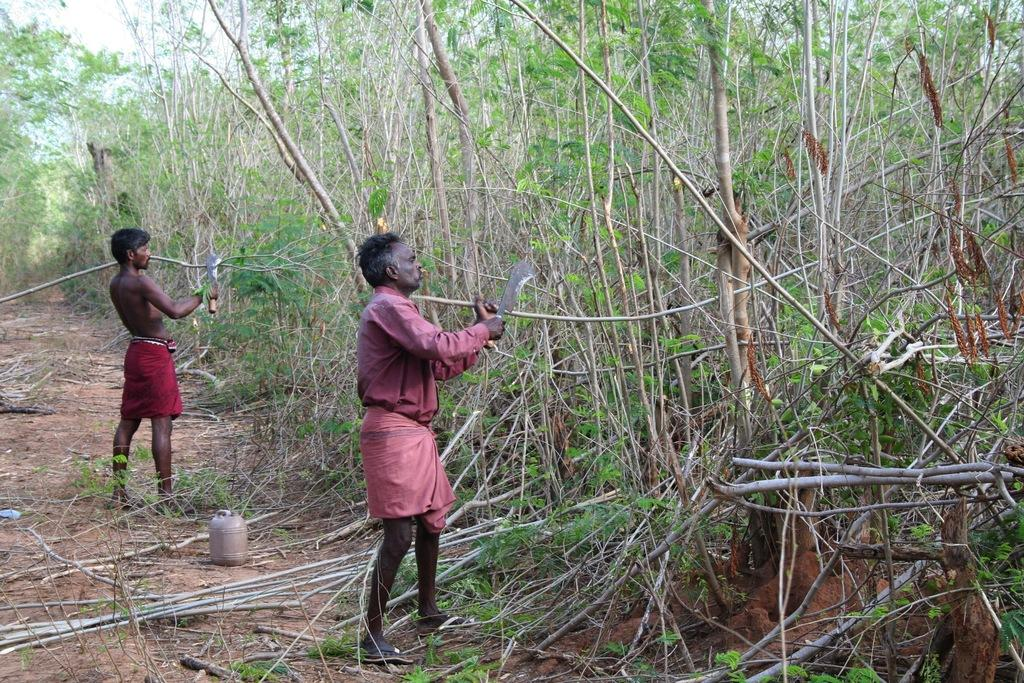How many people are in the image? There are two people in the image. What are the people holding in the image? The people are holding branches and something in the image. What type of natural environment is visible in the image? There are trees and mud visible in the image, suggesting a forest or wooded area. What is visible in the sky in the image? There is sky visible in the image. What objects can be seen on the ground in the image? There are objects on the ground in the image. What type of blood can be seen on the ground in the image? There is no blood visible on the ground in the image. What caused the people to hold branches and objects in the image? The facts provided do not give any information about the cause for the people holding branches and objects in the image. --- Facts: 1. There is a car in the image. 2. The car is parked on the street. 3. There are streetlights in the image. 4. There are buildings in the background of the image. 5. The sky is visible in the image. Absurd Topics: parrot, ocean, dance Conversation: What type of vehicle is in the image? There is a car in the image. Where is the car located in the image? The car is parked on the street in the image. What type of lighting is present in the image? There are streetlights in the image. What type of structures can be seen in the background of the image? There are buildings in the background of the image. What is visible in the sky in the image? The sky is visible in the image. Reasoning: Let's think step by step in order to produce the conversation. We start by identifying the main subject in the image, which is the car. Then, we describe the car's location and the presence of streetlights. Next, we mention the background structures and the sky visible in the image. Each question is designed to elicit a specific detail about the image that is known from the provided facts. Absurd Question/Answer: Can you see a parrot flying over the ocean in the image? There is no parrot or ocean present in the image. What type of dance is being performed in the image? There is no dance or dancing activity depicted in the image. 